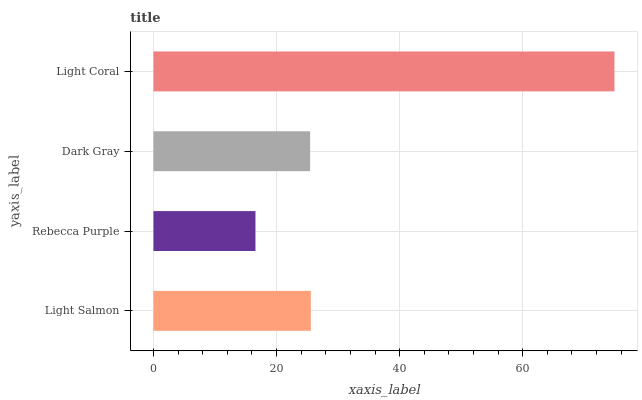Is Rebecca Purple the minimum?
Answer yes or no. Yes. Is Light Coral the maximum?
Answer yes or no. Yes. Is Dark Gray the minimum?
Answer yes or no. No. Is Dark Gray the maximum?
Answer yes or no. No. Is Dark Gray greater than Rebecca Purple?
Answer yes or no. Yes. Is Rebecca Purple less than Dark Gray?
Answer yes or no. Yes. Is Rebecca Purple greater than Dark Gray?
Answer yes or no. No. Is Dark Gray less than Rebecca Purple?
Answer yes or no. No. Is Light Salmon the high median?
Answer yes or no. Yes. Is Dark Gray the low median?
Answer yes or no. Yes. Is Rebecca Purple the high median?
Answer yes or no. No. Is Light Coral the low median?
Answer yes or no. No. 